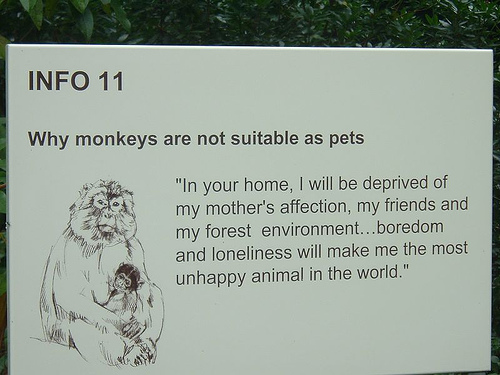<image>
Is there a monkey on the sign? Yes. Looking at the image, I can see the monkey is positioned on top of the sign, with the sign providing support. 